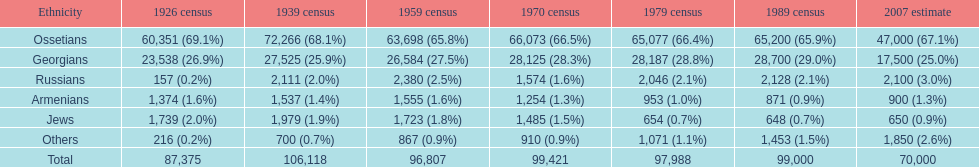Can you give me this table as a dict? {'header': ['Ethnicity', '1926 census', '1939 census', '1959 census', '1970 census', '1979 census', '1989 census', '2007 estimate'], 'rows': [['Ossetians', '60,351 (69.1%)', '72,266 (68.1%)', '63,698 (65.8%)', '66,073 (66.5%)', '65,077 (66.4%)', '65,200 (65.9%)', '47,000 (67.1%)'], ['Georgians', '23,538 (26.9%)', '27,525 (25.9%)', '26,584 (27.5%)', '28,125 (28.3%)', '28,187 (28.8%)', '28,700 (29.0%)', '17,500 (25.0%)'], ['Russians', '157 (0.2%)', '2,111 (2.0%)', '2,380 (2.5%)', '1,574 (1.6%)', '2,046 (2.1%)', '2,128 (2.1%)', '2,100 (3.0%)'], ['Armenians', '1,374 (1.6%)', '1,537 (1.4%)', '1,555 (1.6%)', '1,254 (1.3%)', '953 (1.0%)', '871 (0.9%)', '900 (1.3%)'], ['Jews', '1,739 (2.0%)', '1,979 (1.9%)', '1,723 (1.8%)', '1,485 (1.5%)', '654 (0.7%)', '648 (0.7%)', '650 (0.9%)'], ['Others', '216 (0.2%)', '700 (0.7%)', '867 (0.9%)', '910 (0.9%)', '1,071 (1.1%)', '1,453 (1.5%)', '1,850 (2.6%)'], ['Total', '87,375', '106,118', '96,807', '99,421', '97,988', '99,000', '70,000']]} How many russians lived in south ossetia in 1970? 1,574. 